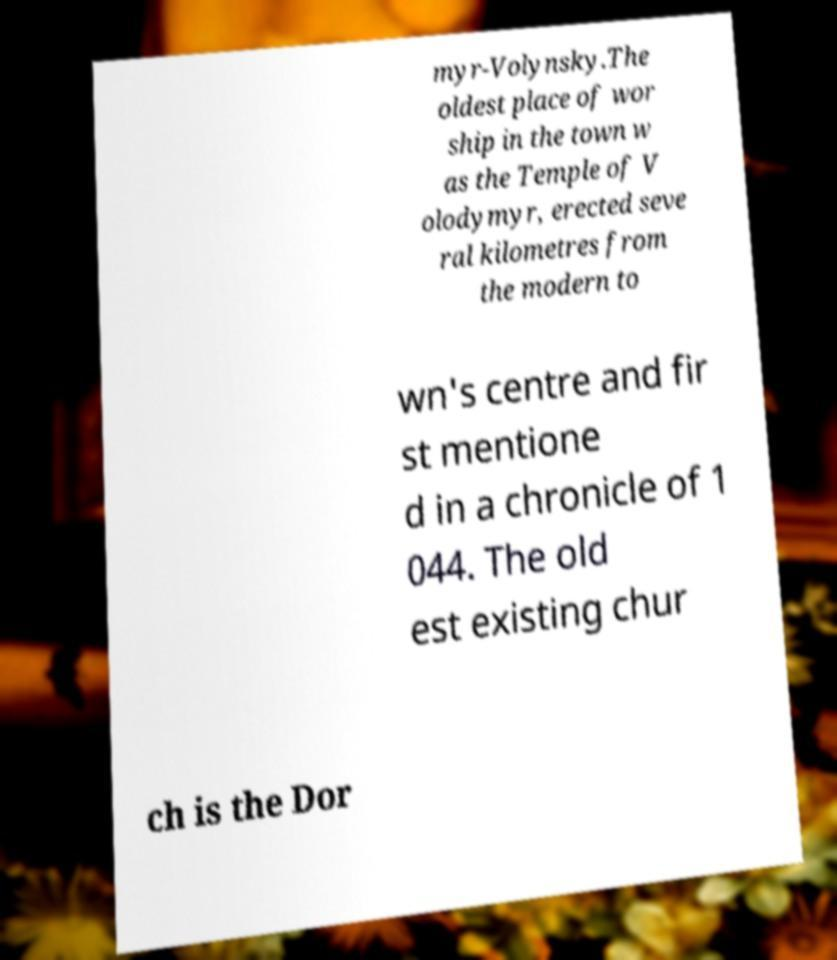Please read and relay the text visible in this image. What does it say? myr-Volynsky.The oldest place of wor ship in the town w as the Temple of V olodymyr, erected seve ral kilometres from the modern to wn's centre and fir st mentione d in a chronicle of 1 044. The old est existing chur ch is the Dor 